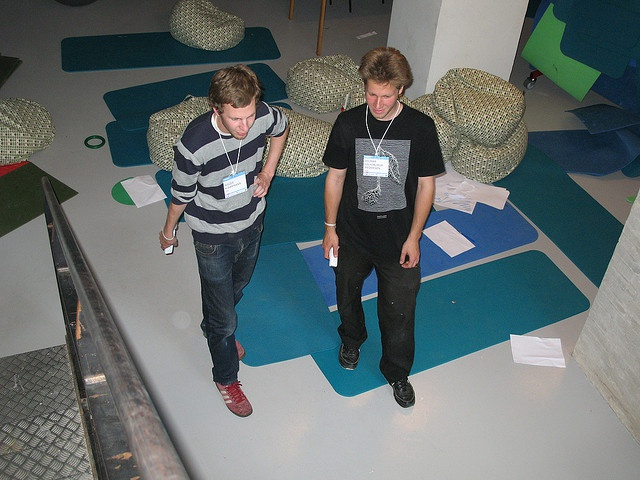Describe the objects in this image and their specific colors. I can see people in black, gray, and darkgray tones, people in black, darkgray, and gray tones, remote in black, white, darkgray, and gray tones, and remote in black, lightgray, darkgray, and gray tones in this image. 